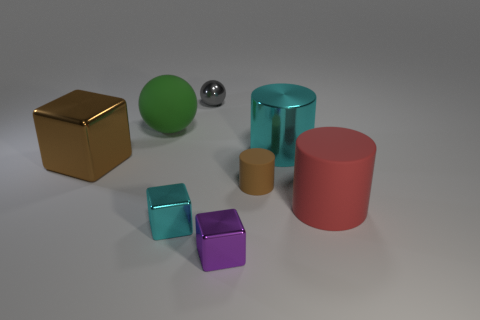Is the color of the big metal block the same as the matte cylinder left of the large matte cylinder?
Your response must be concise. Yes. There is a tiny gray object that is the same shape as the green thing; what is its material?
Provide a succinct answer. Metal. What material is the gray thing?
Keep it short and to the point. Metal. There is a thing behind the matte object that is behind the large object that is to the left of the green matte ball; what is it made of?
Provide a short and direct response. Metal. Is the size of the red rubber object the same as the cyan thing that is in front of the brown block?
Offer a terse response. No. What number of objects are either small metal things that are left of the small gray metallic ball or objects left of the small rubber thing?
Offer a terse response. 5. The cube that is behind the tiny brown matte cylinder is what color?
Ensure brevity in your answer.  Brown. Is there a brown cylinder that is in front of the metal object to the right of the small purple metallic cube?
Your response must be concise. Yes. Is the number of red things less than the number of tiny objects?
Provide a succinct answer. Yes. What material is the cyan object that is in front of the cylinder that is behind the big block?
Your answer should be very brief. Metal. 